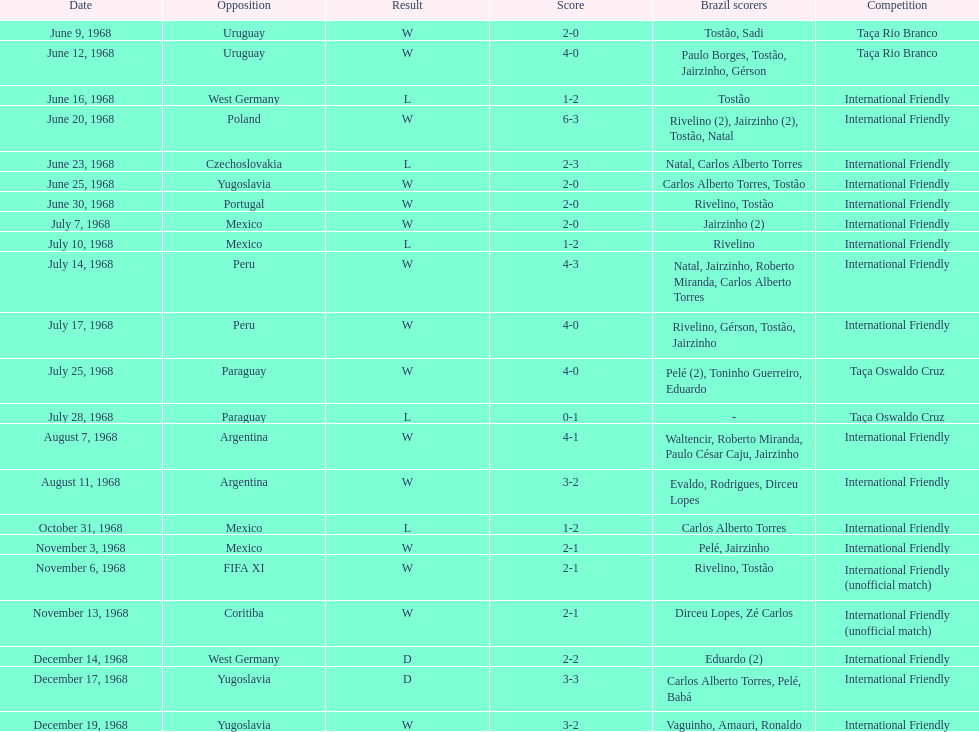Who played brazil previous to the game on june 30th? Yugoslavia. 